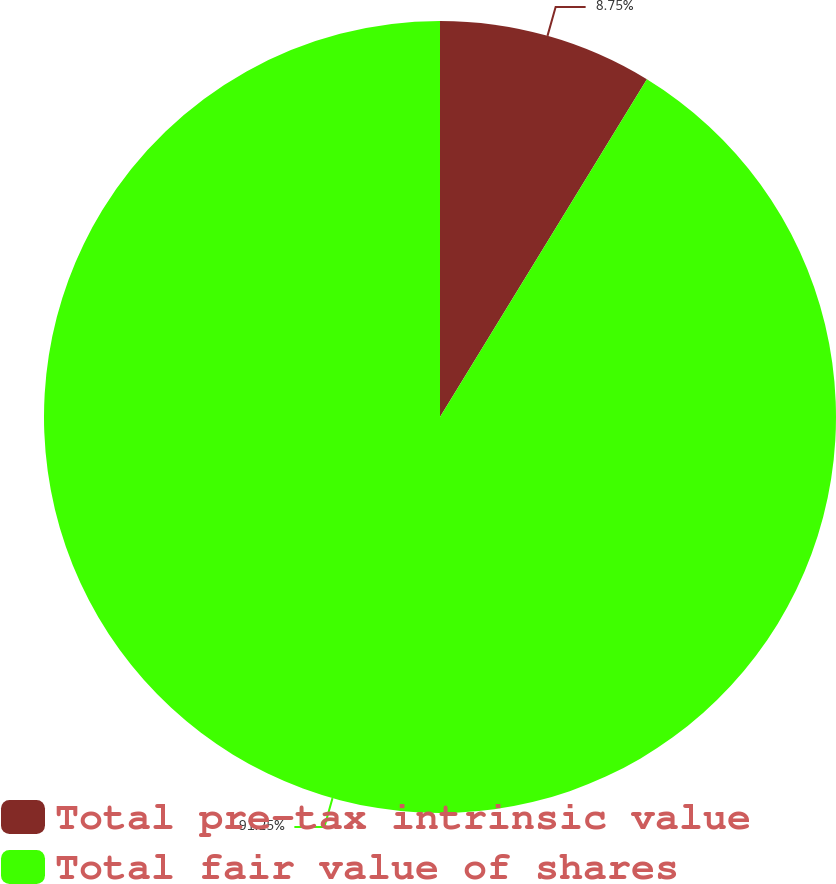<chart> <loc_0><loc_0><loc_500><loc_500><pie_chart><fcel>Total pre-tax intrinsic value<fcel>Total fair value of shares<nl><fcel>8.75%<fcel>91.25%<nl></chart> 